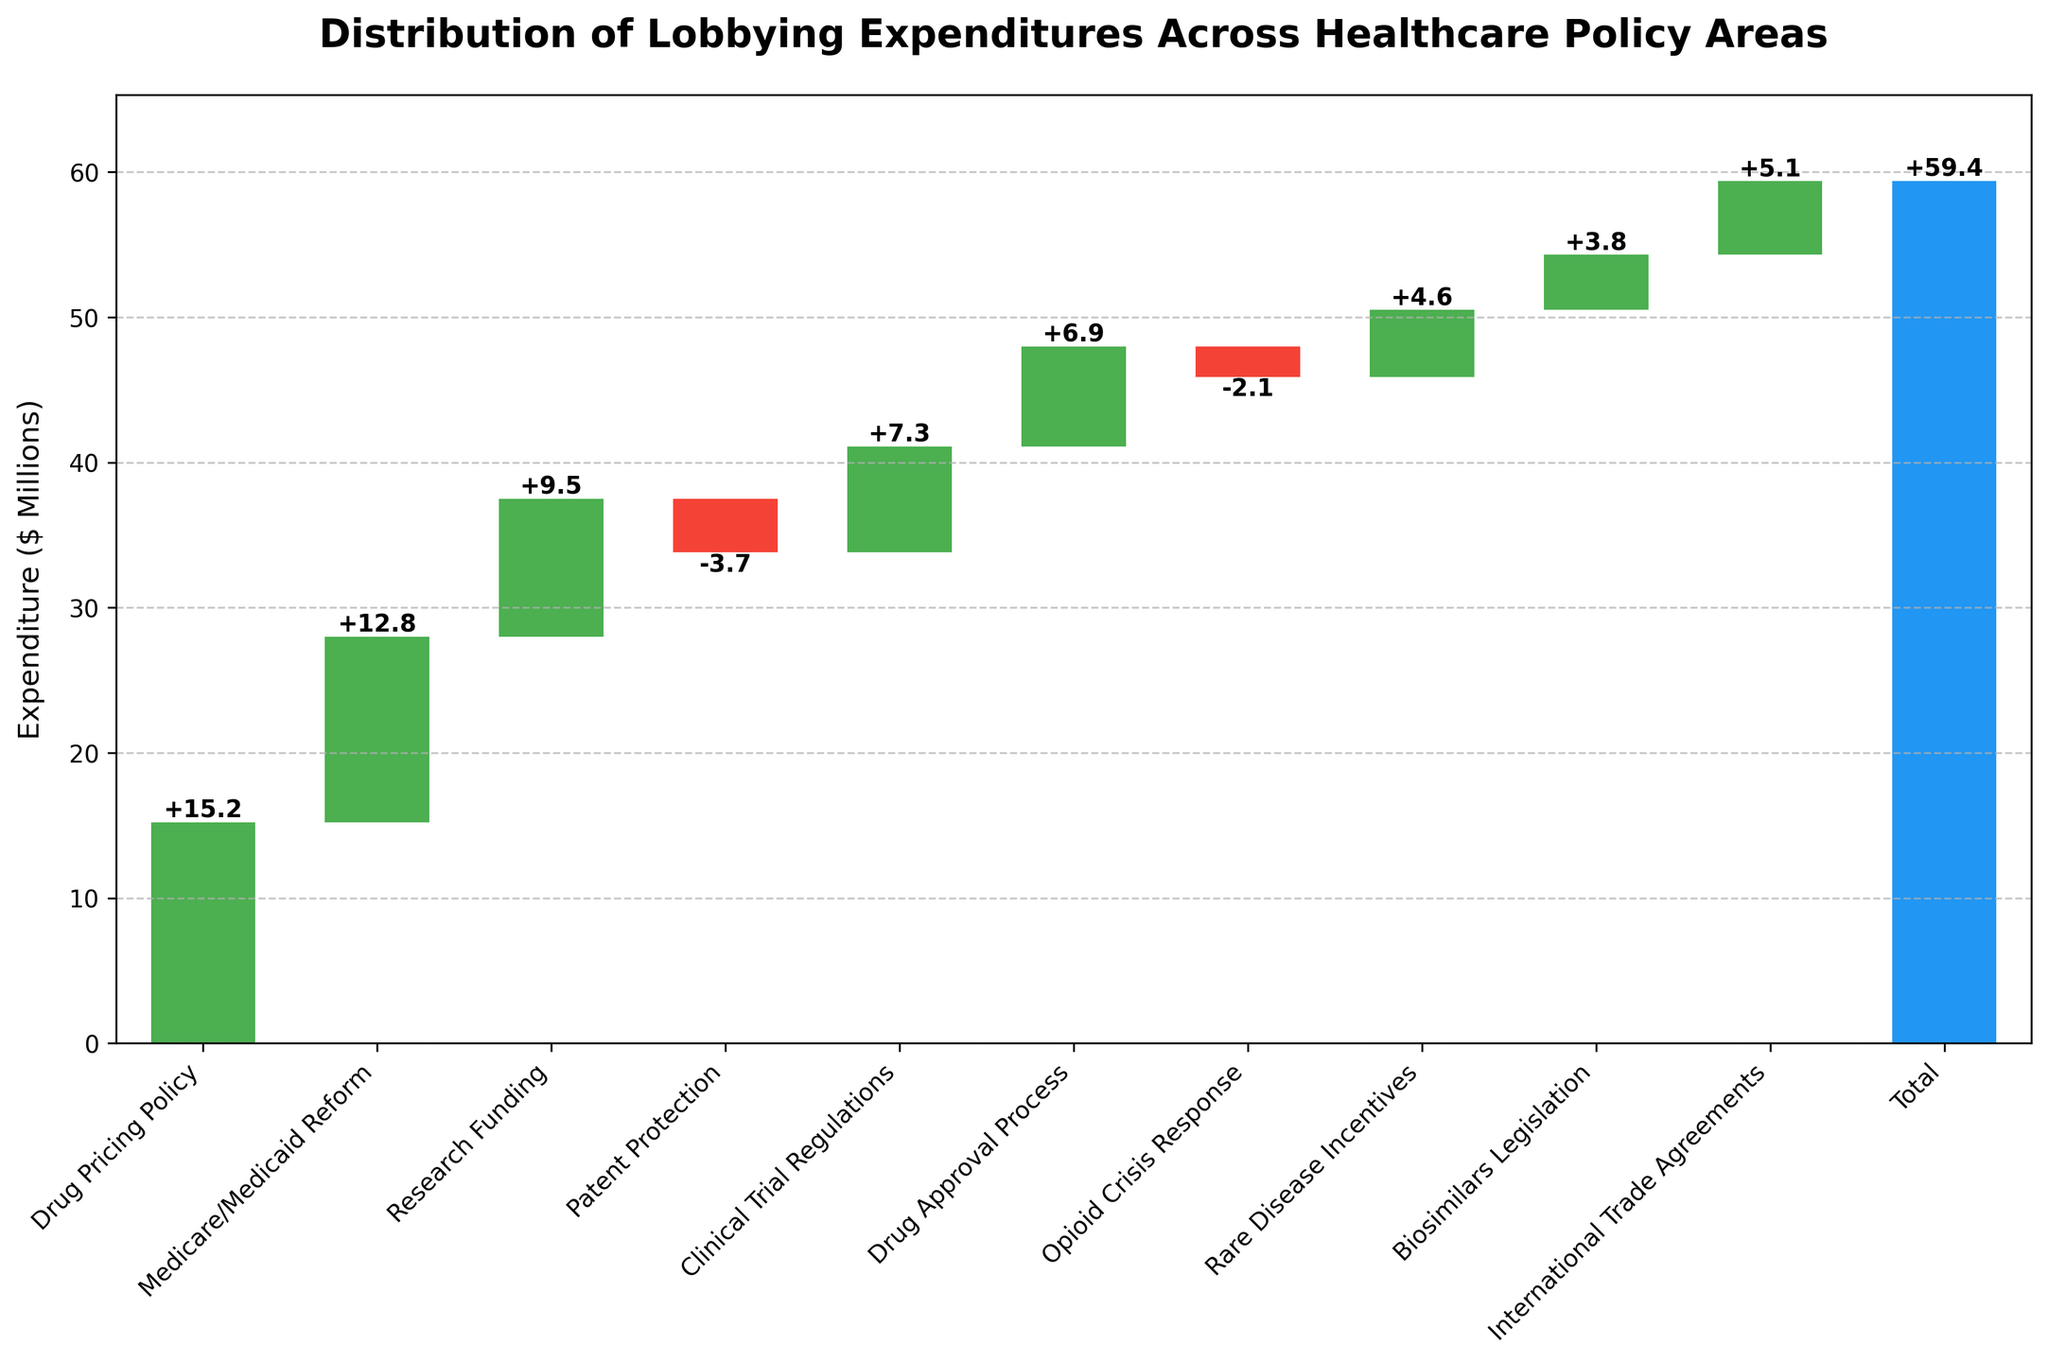what is the total lobbying expenditure shown in the plot? The total lobbying expenditure is represented by the bar labeled 'Total' at the far right of the plot. This figure shows the total amount spent across all categories combined.
Answer: 59.4 Compare the lobbying expenditures for Research Funding and Patent Protection? Research Funding has a positive value of 9.5 million, which is depicted by a green bar. Patent Protection, on the other hand, has a negative value of -3.7 million, shown by a red bar. Thus, Research Funding received more lobbying expenditure than Patent Protection.
Answer: Research Funding is higher Which category has the highest positive lobbying expenditure? By inspecting the length of the green bars (positive values), the Drug Pricing Policy category has the highest bar among all categories, indicating it has the highest expenditure of 15.2 million.
Answer: Drug Pricing Policy What is the net effect of categories with negative expenditures on the total expenditure? The negative categories are Patent Protection (-3.7 million) and Opioid Crisis Response (-2.1 million). The net effect is their sum, which is -3.7 - 2.1 = -5.8 million.
Answer: -5.8 How do Medicare/Medicaid Reform and Drug Approval Process expenditures compare in terms of their value relative to each other? Medicare/Medicaid Reform has an expenditure of 12.8 million, while Drug Approval Process has 6.9 million. To determine how much more or less one is compared to the other, calculate the difference: 12.8 - 6.9 = 5.9 million. Thus, Medicare/Medicaid Reform has 5.9 million higher lobbying expenditure than Drug Approval Process.
Answer: Medicare/Medicaid Reform is 5.9 million higher What is the cumulative lobbying expenditure after including Clinical Trial Regulations? Start with the first category, continuing to add each subsequent category up to Clinical Trial Regulations. So, Drug Pricing Policy (15.2) + Medicare/Medicaid Reform (12.8) + Research Funding (9.5) + Patent Protection (-3.7) + Clinical Trial Regulations (7.3) = 41.1 million.
Answer: 41.1 Which categories have values that reduce the total lobbying expenditure? Categories with negative values include Patent Protection (-3.7) and Opioid Crisis Response (-2.1). These are shown with red bars in the plot.
Answer: Patent Protection and Opioid Crisis Response What is the average lobbying expenditure across all categories excluding the total? Sum all the category expenditures except the 'Total': 15.2 + 12.8 + 9.5 - 3.7 + 7.3 + 6.9 - 2.1 + 4.6 + 3.8 + 5.1 = 59.4. Then, divide by the number of categories excluded 'Total', which is 10. 59.4 / 10 = 5.94 million.
Answer: 5.94 million 